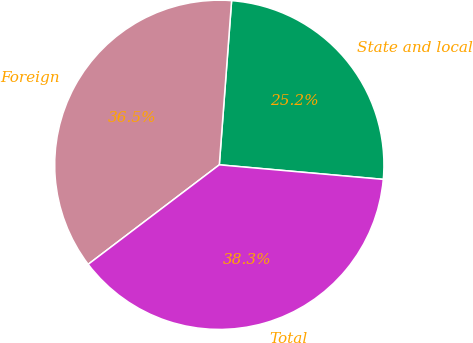Convert chart to OTSL. <chart><loc_0><loc_0><loc_500><loc_500><pie_chart><fcel>State and local<fcel>Foreign<fcel>Total<nl><fcel>25.22%<fcel>36.52%<fcel>38.26%<nl></chart> 